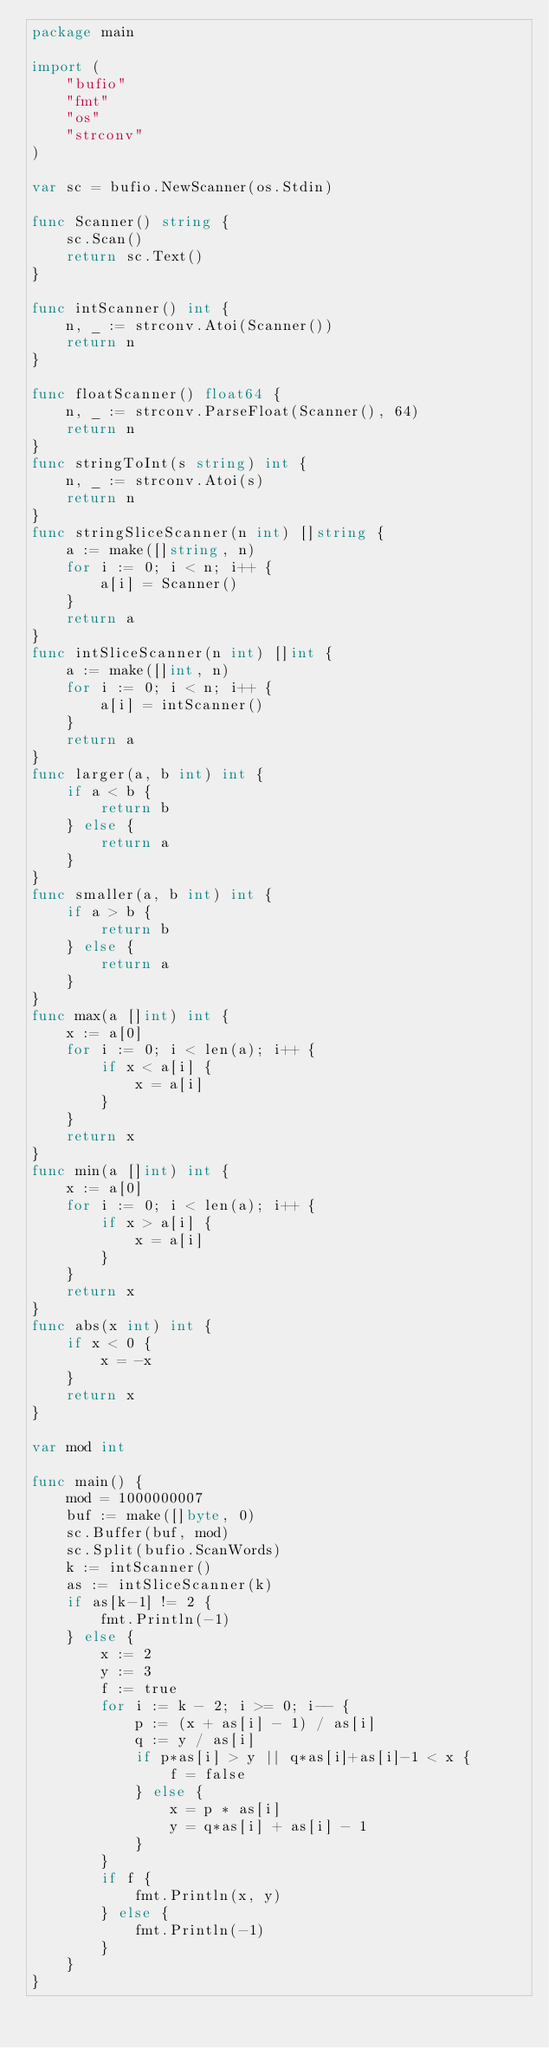<code> <loc_0><loc_0><loc_500><loc_500><_Go_>package main

import (
	"bufio"
	"fmt"
	"os"
	"strconv"
)

var sc = bufio.NewScanner(os.Stdin)

func Scanner() string {
	sc.Scan()
	return sc.Text()
}

func intScanner() int {
	n, _ := strconv.Atoi(Scanner())
	return n
}

func floatScanner() float64 {
	n, _ := strconv.ParseFloat(Scanner(), 64)
	return n
}
func stringToInt(s string) int {
	n, _ := strconv.Atoi(s)
	return n
}
func stringSliceScanner(n int) []string {
	a := make([]string, n)
	for i := 0; i < n; i++ {
		a[i] = Scanner()
	}
	return a
}
func intSliceScanner(n int) []int {
	a := make([]int, n)
	for i := 0; i < n; i++ {
		a[i] = intScanner()
	}
	return a
}
func larger(a, b int) int {
	if a < b {
		return b
	} else {
		return a
	}
}
func smaller(a, b int) int {
	if a > b {
		return b
	} else {
		return a
	}
}
func max(a []int) int {
	x := a[0]
	for i := 0; i < len(a); i++ {
		if x < a[i] {
			x = a[i]
		}
	}
	return x
}
func min(a []int) int {
	x := a[0]
	for i := 0; i < len(a); i++ {
		if x > a[i] {
			x = a[i]
		}
	}
	return x
}
func abs(x int) int {
	if x < 0 {
		x = -x
	}
	return x
}

var mod int

func main() {
	mod = 1000000007
	buf := make([]byte, 0)
	sc.Buffer(buf, mod)
	sc.Split(bufio.ScanWords)
	k := intScanner()
	as := intSliceScanner(k)
	if as[k-1] != 2 {
		fmt.Println(-1)
	} else {
		x := 2
		y := 3
		f := true
		for i := k - 2; i >= 0; i-- {
			p := (x + as[i] - 1) / as[i]
			q := y / as[i]
			if p*as[i] > y || q*as[i]+as[i]-1 < x {
				f = false
			} else {
				x = p * as[i]
				y = q*as[i] + as[i] - 1
			}
		}
		if f {
			fmt.Println(x, y)
		} else {
			fmt.Println(-1)
		}
	}
}
</code> 